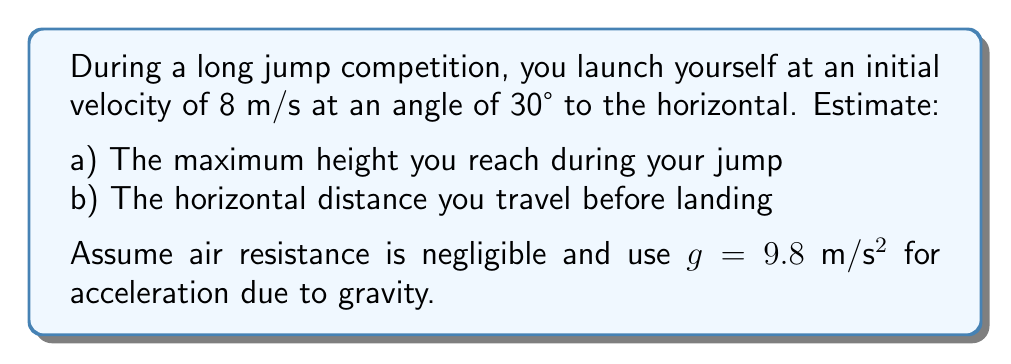What is the answer to this math problem? Let's approach this problem step-by-step using the equations of motion for projectile motion.

1) First, let's break down the initial velocity into its horizontal and vertical components:
   $v_x = v \cos \theta = 8 \cos 30° = 8 \cdot \frac{\sqrt{3}}{2} = 4\sqrt{3}$ m/s
   $v_y = v \sin \theta = 8 \sin 30° = 8 \cdot \frac{1}{2} = 4$ m/s

a) To find the maximum height:

2) Use the equation: $h = \frac{v_y^2}{2g}$
   $h = \frac{4^2}{2(9.8)} = \frac{16}{19.6} \approx 0.82$ m

b) To find the horizontal distance:

3) First, calculate the time of flight. The vertical displacement is zero at the landing point:
   $0 = v_y t - \frac{1}{2}gt^2$
   $0 = 4t - 4.9t^2$
   $4.9t^2 = 4t$
   $t(4.9t - 4) = 0$
   $t = 0$ or $t = \frac{4}{4.9} \approx 0.82$ s

4) Now use the horizontal component of velocity to find the distance:
   $d = v_x t = 4\sqrt{3} \cdot 0.82 \approx 5.68$ m

Therefore, the maximum height is approximately 0.82 m, and the horizontal distance traveled is approximately 5.68 m.
Answer: a) 0.82 m
b) 5.68 m 